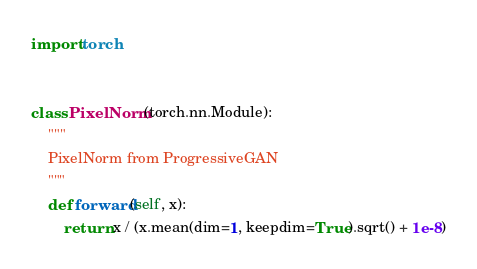<code> <loc_0><loc_0><loc_500><loc_500><_Python_>import torch


class PixelNorm(torch.nn.Module):
    """
    PixelNorm from ProgressiveGAN
    """
    def forward(self, x):
        return x / (x.mean(dim=1, keepdim=True).sqrt() + 1e-8)
</code> 